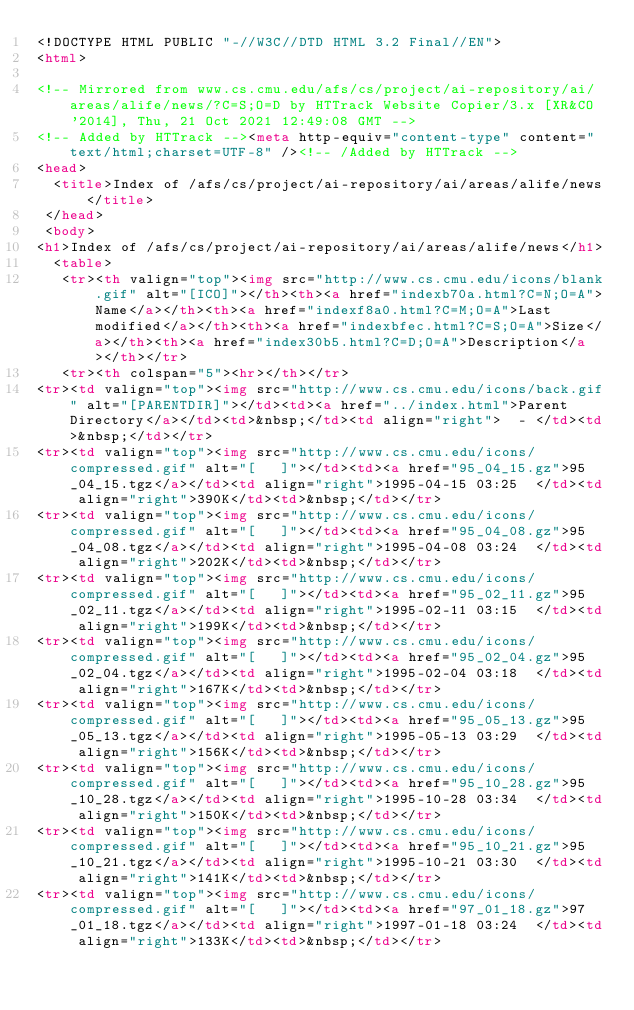Convert code to text. <code><loc_0><loc_0><loc_500><loc_500><_HTML_><!DOCTYPE HTML PUBLIC "-//W3C//DTD HTML 3.2 Final//EN">
<html>
 
<!-- Mirrored from www.cs.cmu.edu/afs/cs/project/ai-repository/ai/areas/alife/news/?C=S;O=D by HTTrack Website Copier/3.x [XR&CO'2014], Thu, 21 Oct 2021 12:49:08 GMT -->
<!-- Added by HTTrack --><meta http-equiv="content-type" content="text/html;charset=UTF-8" /><!-- /Added by HTTrack -->
<head>
  <title>Index of /afs/cs/project/ai-repository/ai/areas/alife/news</title>
 </head>
 <body>
<h1>Index of /afs/cs/project/ai-repository/ai/areas/alife/news</h1>
  <table>
   <tr><th valign="top"><img src="http://www.cs.cmu.edu/icons/blank.gif" alt="[ICO]"></th><th><a href="indexb70a.html?C=N;O=A">Name</a></th><th><a href="indexf8a0.html?C=M;O=A">Last modified</a></th><th><a href="indexbfec.html?C=S;O=A">Size</a></th><th><a href="index30b5.html?C=D;O=A">Description</a></th></tr>
   <tr><th colspan="5"><hr></th></tr>
<tr><td valign="top"><img src="http://www.cs.cmu.edu/icons/back.gif" alt="[PARENTDIR]"></td><td><a href="../index.html">Parent Directory</a></td><td>&nbsp;</td><td align="right">  - </td><td>&nbsp;</td></tr>
<tr><td valign="top"><img src="http://www.cs.cmu.edu/icons/compressed.gif" alt="[   ]"></td><td><a href="95_04_15.gz">95_04_15.tgz</a></td><td align="right">1995-04-15 03:25  </td><td align="right">390K</td><td>&nbsp;</td></tr>
<tr><td valign="top"><img src="http://www.cs.cmu.edu/icons/compressed.gif" alt="[   ]"></td><td><a href="95_04_08.gz">95_04_08.tgz</a></td><td align="right">1995-04-08 03:24  </td><td align="right">202K</td><td>&nbsp;</td></tr>
<tr><td valign="top"><img src="http://www.cs.cmu.edu/icons/compressed.gif" alt="[   ]"></td><td><a href="95_02_11.gz">95_02_11.tgz</a></td><td align="right">1995-02-11 03:15  </td><td align="right">199K</td><td>&nbsp;</td></tr>
<tr><td valign="top"><img src="http://www.cs.cmu.edu/icons/compressed.gif" alt="[   ]"></td><td><a href="95_02_04.gz">95_02_04.tgz</a></td><td align="right">1995-02-04 03:18  </td><td align="right">167K</td><td>&nbsp;</td></tr>
<tr><td valign="top"><img src="http://www.cs.cmu.edu/icons/compressed.gif" alt="[   ]"></td><td><a href="95_05_13.gz">95_05_13.tgz</a></td><td align="right">1995-05-13 03:29  </td><td align="right">156K</td><td>&nbsp;</td></tr>
<tr><td valign="top"><img src="http://www.cs.cmu.edu/icons/compressed.gif" alt="[   ]"></td><td><a href="95_10_28.gz">95_10_28.tgz</a></td><td align="right">1995-10-28 03:34  </td><td align="right">150K</td><td>&nbsp;</td></tr>
<tr><td valign="top"><img src="http://www.cs.cmu.edu/icons/compressed.gif" alt="[   ]"></td><td><a href="95_10_21.gz">95_10_21.tgz</a></td><td align="right">1995-10-21 03:30  </td><td align="right">141K</td><td>&nbsp;</td></tr>
<tr><td valign="top"><img src="http://www.cs.cmu.edu/icons/compressed.gif" alt="[   ]"></td><td><a href="97_01_18.gz">97_01_18.tgz</a></td><td align="right">1997-01-18 03:24  </td><td align="right">133K</td><td>&nbsp;</td></tr></code> 